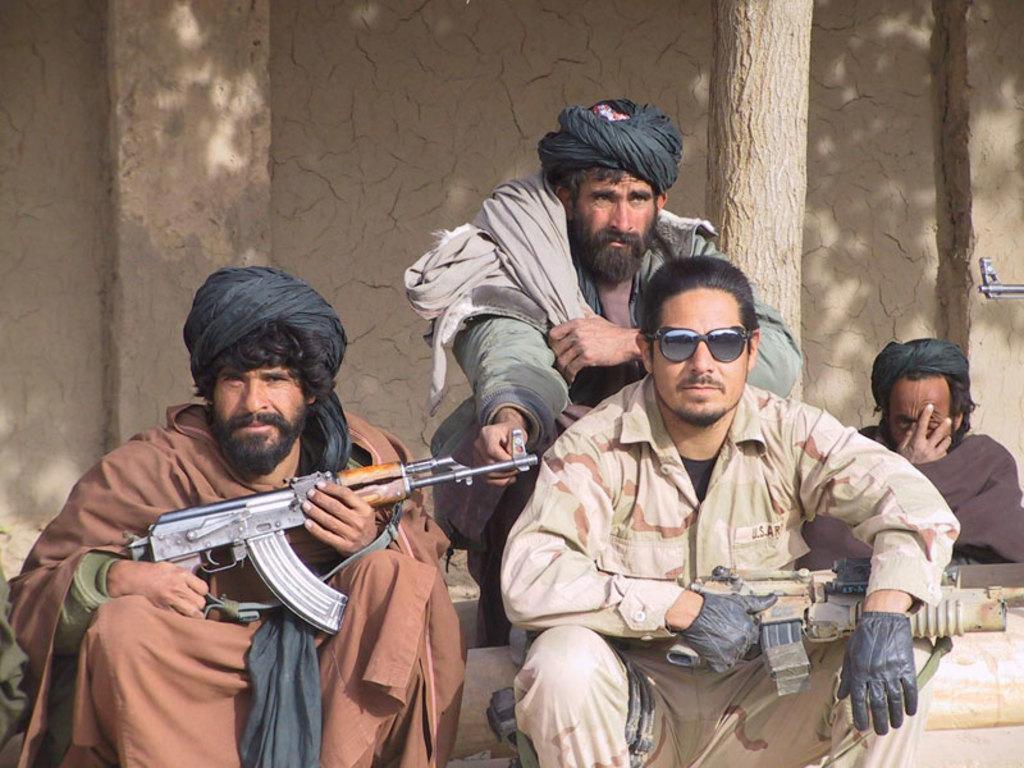Can you describe this image briefly? In this image I can see few people and two people are holding the guns and wearing different color dresses. I can see the branch and the brown color wall. 